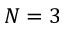Convert formula to latex. <formula><loc_0><loc_0><loc_500><loc_500>N = 3</formula> 